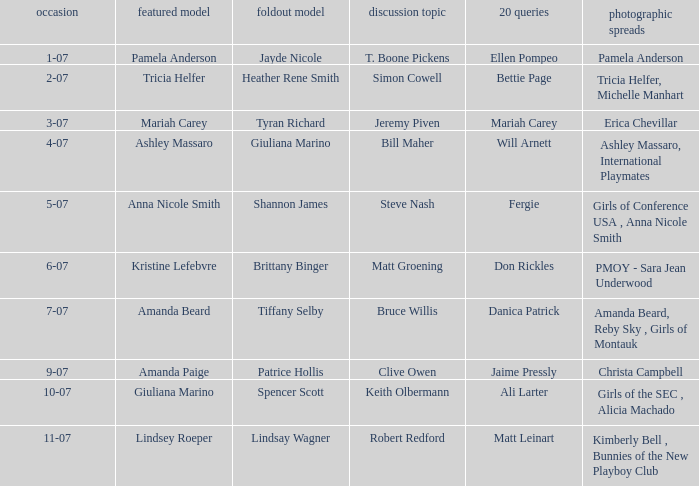Parse the table in full. {'header': ['occasion', 'featured model', 'foldout model', 'discussion topic', '20 queries', 'photographic spreads'], 'rows': [['1-07', 'Pamela Anderson', 'Jayde Nicole', 'T. Boone Pickens', 'Ellen Pompeo', 'Pamela Anderson'], ['2-07', 'Tricia Helfer', 'Heather Rene Smith', 'Simon Cowell', 'Bettie Page', 'Tricia Helfer, Michelle Manhart'], ['3-07', 'Mariah Carey', 'Tyran Richard', 'Jeremy Piven', 'Mariah Carey', 'Erica Chevillar'], ['4-07', 'Ashley Massaro', 'Giuliana Marino', 'Bill Maher', 'Will Arnett', 'Ashley Massaro, International Playmates'], ['5-07', 'Anna Nicole Smith', 'Shannon James', 'Steve Nash', 'Fergie', 'Girls of Conference USA , Anna Nicole Smith'], ['6-07', 'Kristine Lefebvre', 'Brittany Binger', 'Matt Groening', 'Don Rickles', 'PMOY - Sara Jean Underwood'], ['7-07', 'Amanda Beard', 'Tiffany Selby', 'Bruce Willis', 'Danica Patrick', 'Amanda Beard, Reby Sky , Girls of Montauk'], ['9-07', 'Amanda Paige', 'Patrice Hollis', 'Clive Owen', 'Jaime Pressly', 'Christa Campbell'], ['10-07', 'Giuliana Marino', 'Spencer Scott', 'Keith Olbermann', 'Ali Larter', 'Girls of the SEC , Alicia Machado'], ['11-07', 'Lindsey Roeper', 'Lindsay Wagner', 'Robert Redford', 'Matt Leinart', 'Kimberly Bell , Bunnies of the New Playboy Club']]} Who provided answers to the 20 questions on october 7th? Ali Larter. 